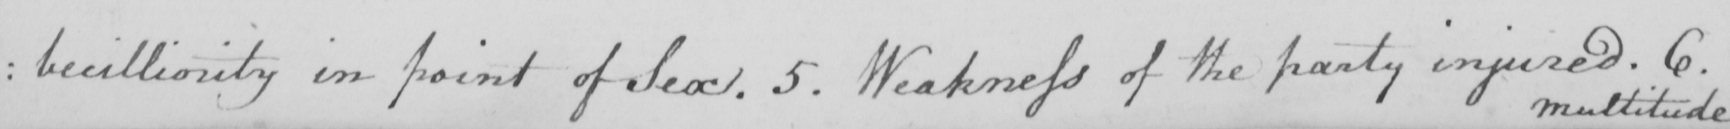Can you read and transcribe this handwriting? : becilliority in point of Sex . 5 . Weakness of the party injured . 6 . 